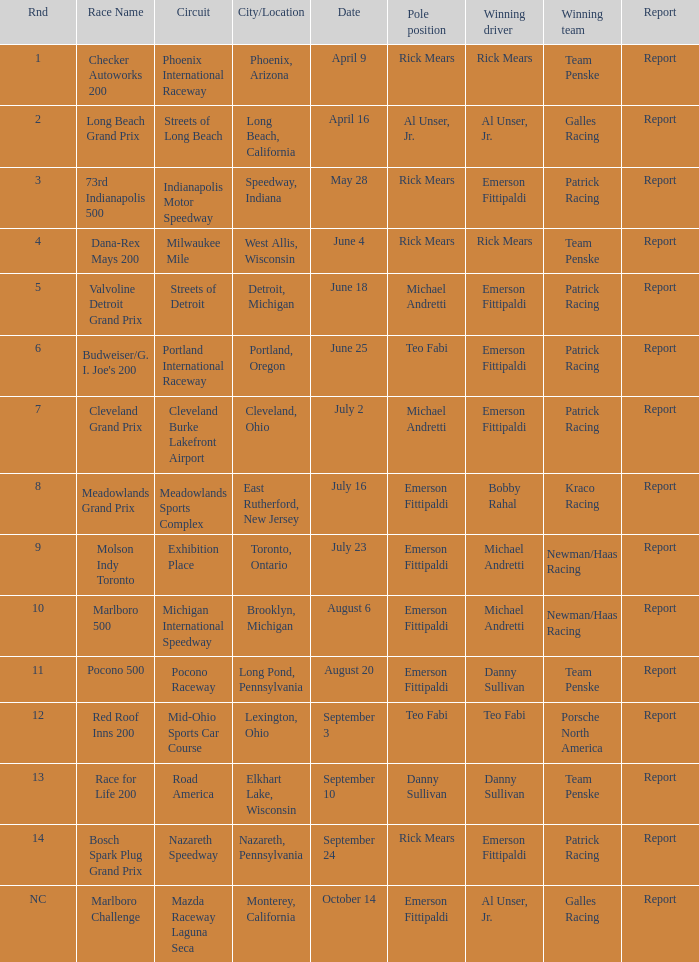Who was the pole position for the rnd equalling 12? Teo Fabi. 